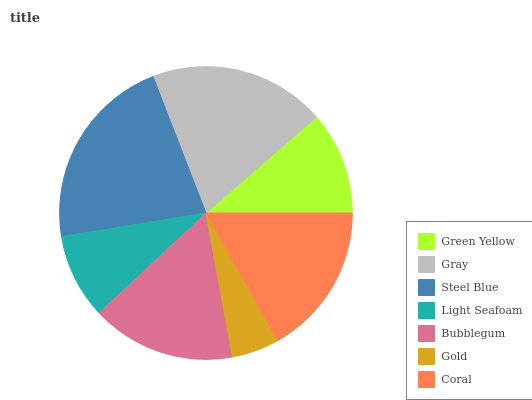Is Gold the minimum?
Answer yes or no. Yes. Is Steel Blue the maximum?
Answer yes or no. Yes. Is Gray the minimum?
Answer yes or no. No. Is Gray the maximum?
Answer yes or no. No. Is Gray greater than Green Yellow?
Answer yes or no. Yes. Is Green Yellow less than Gray?
Answer yes or no. Yes. Is Green Yellow greater than Gray?
Answer yes or no. No. Is Gray less than Green Yellow?
Answer yes or no. No. Is Bubblegum the high median?
Answer yes or no. Yes. Is Bubblegum the low median?
Answer yes or no. Yes. Is Green Yellow the high median?
Answer yes or no. No. Is Coral the low median?
Answer yes or no. No. 